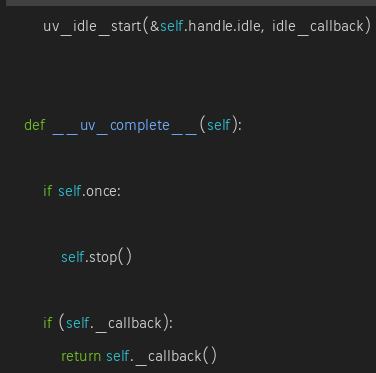Convert code to text. <code><loc_0><loc_0><loc_500><loc_500><_Cython_>
        uv_idle_start(&self.handle.idle, idle_callback)


    def __uv_complete__(self):

        if self.once:

            self.stop()

        if (self._callback):
            return self._callback()


</code> 